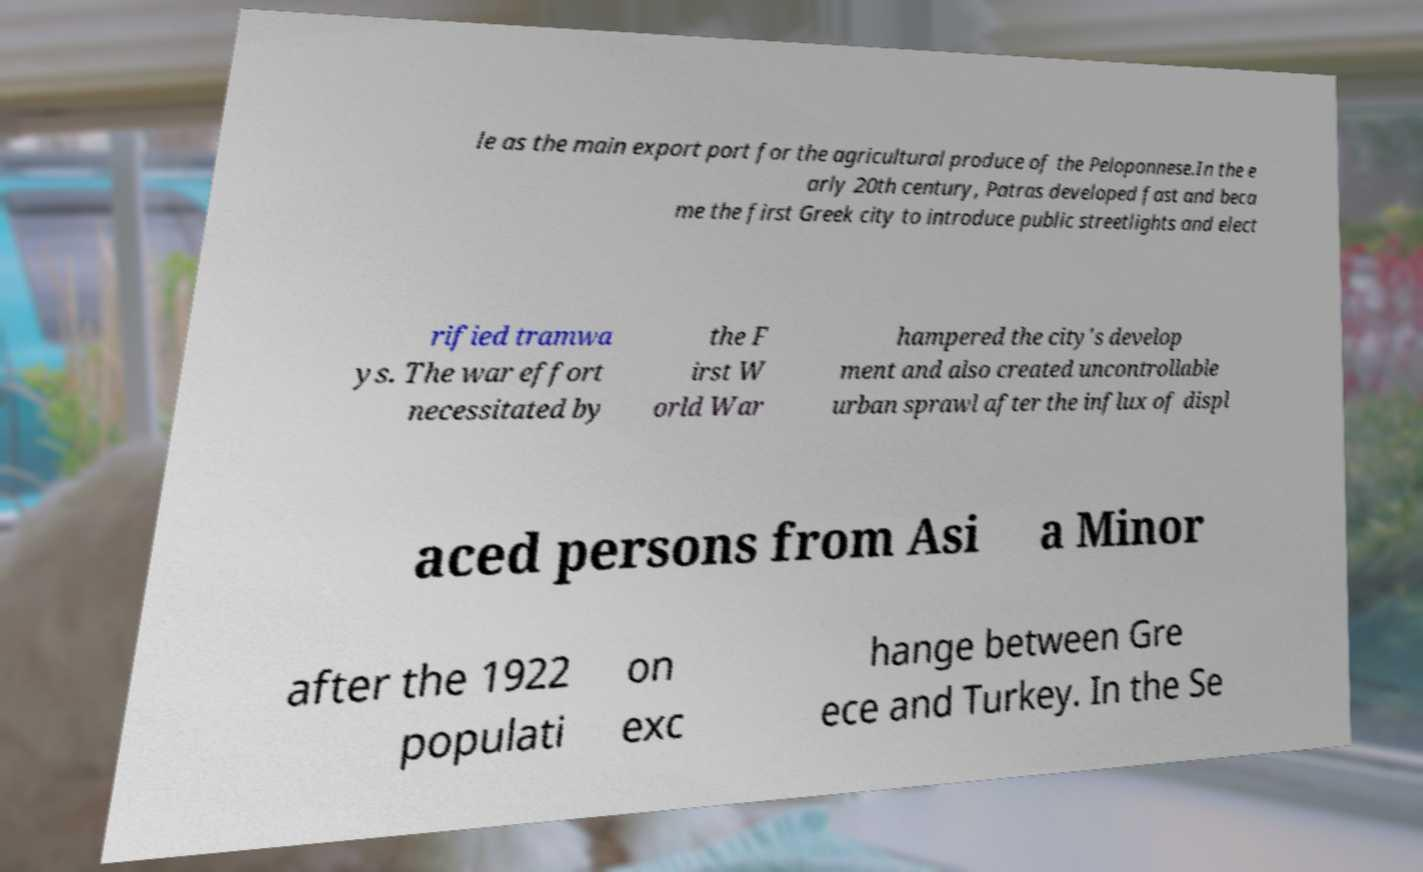Please read and relay the text visible in this image. What does it say? le as the main export port for the agricultural produce of the Peloponnese.In the e arly 20th century, Patras developed fast and beca me the first Greek city to introduce public streetlights and elect rified tramwa ys. The war effort necessitated by the F irst W orld War hampered the city's develop ment and also created uncontrollable urban sprawl after the influx of displ aced persons from Asi a Minor after the 1922 populati on exc hange between Gre ece and Turkey. In the Se 